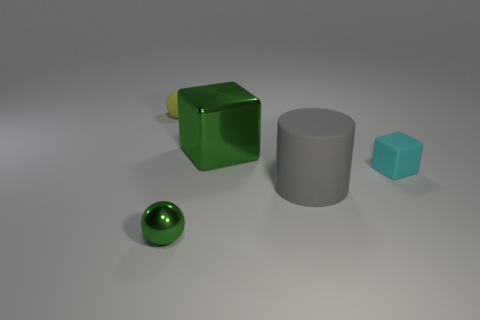There is a green metal object that is behind the small green ball; what number of cyan things are on the left side of it?
Give a very brief answer. 0. There is a tiny object that is the same color as the large metallic block; what is its material?
Provide a short and direct response. Metal. How many other things are the same color as the small cube?
Provide a succinct answer. 0. What color is the small sphere that is in front of the object to the left of the small green ball?
Offer a terse response. Green. Are there any spheres that have the same color as the large metal block?
Make the answer very short. Yes. How many shiny things are either small things or cyan blocks?
Your response must be concise. 1. Are there any big green cubes that have the same material as the tiny yellow ball?
Offer a terse response. No. What number of tiny objects are behind the rubber cylinder and in front of the yellow rubber object?
Your answer should be compact. 1. Are there fewer large rubber objects to the left of the green cube than small yellow matte balls in front of the tiny cyan rubber object?
Offer a very short reply. No. Do the tiny cyan object and the large green thing have the same shape?
Give a very brief answer. Yes. 